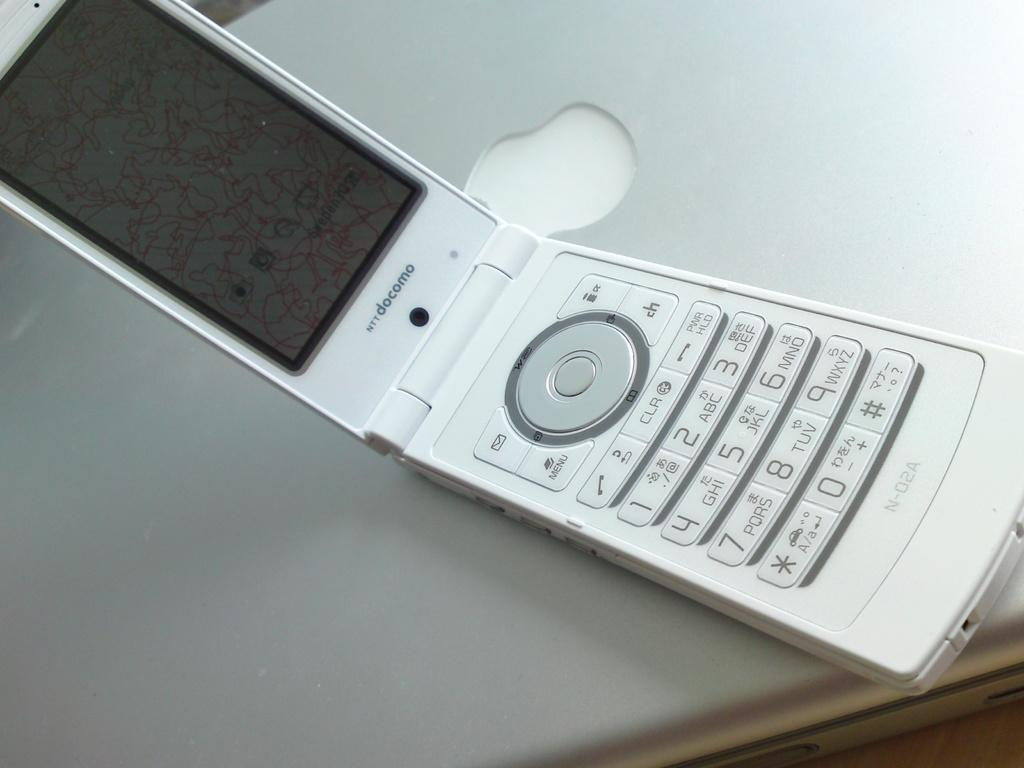Provide a one-sentence caption for the provided image. An open flip phone with the serial number N-02A printed on the bottom. 